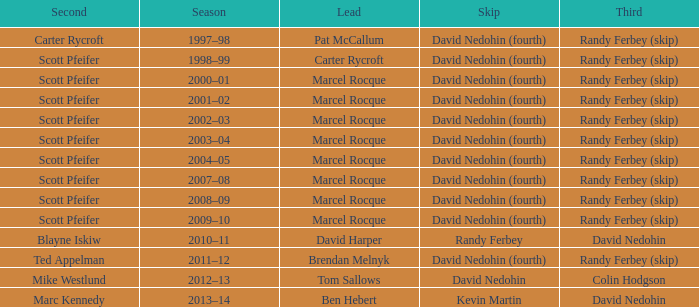Which Skip has a Season of 2002–03? David Nedohin (fourth). 